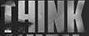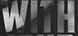Transcribe the words shown in these images in order, separated by a semicolon. THINK; WITH 